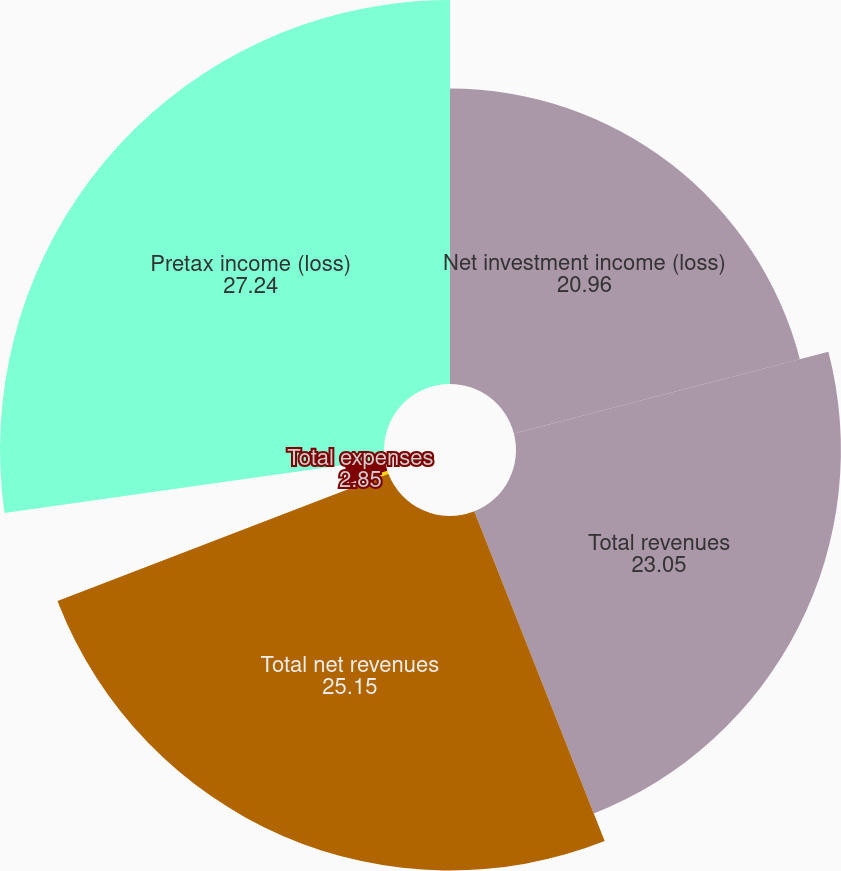<chart> <loc_0><loc_0><loc_500><loc_500><pie_chart><fcel>Net investment income (loss)<fcel>Total revenues<fcel>Total net revenues<fcel>General and administrative<fcel>Total expenses<fcel>Pretax income (loss)<nl><fcel>20.96%<fcel>23.05%<fcel>25.15%<fcel>0.76%<fcel>2.85%<fcel>27.24%<nl></chart> 